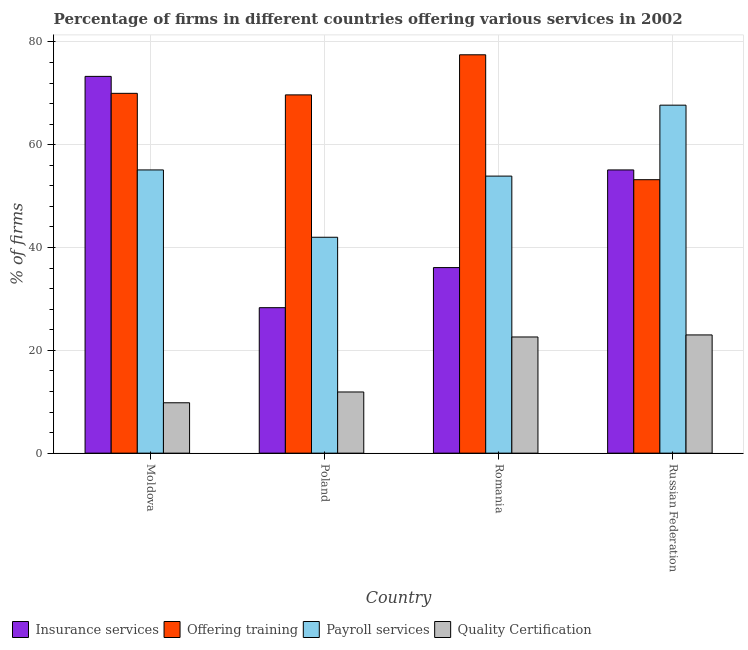Are the number of bars per tick equal to the number of legend labels?
Offer a very short reply. Yes. What is the label of the 1st group of bars from the left?
Your answer should be very brief. Moldova. In how many cases, is the number of bars for a given country not equal to the number of legend labels?
Give a very brief answer. 0. Across all countries, what is the maximum percentage of firms offering payroll services?
Ensure brevity in your answer.  67.7. Across all countries, what is the minimum percentage of firms offering payroll services?
Give a very brief answer. 42. In which country was the percentage of firms offering insurance services maximum?
Offer a terse response. Moldova. In which country was the percentage of firms offering insurance services minimum?
Offer a very short reply. Poland. What is the total percentage of firms offering training in the graph?
Keep it short and to the point. 270.4. What is the difference between the percentage of firms offering payroll services in Poland and that in Romania?
Make the answer very short. -11.9. What is the difference between the percentage of firms offering training in Romania and the percentage of firms offering insurance services in Russian Federation?
Ensure brevity in your answer.  22.4. What is the average percentage of firms offering quality certification per country?
Offer a terse response. 16.83. What is the difference between the percentage of firms offering training and percentage of firms offering insurance services in Poland?
Offer a very short reply. 41.4. What is the ratio of the percentage of firms offering training in Poland to that in Romania?
Your answer should be very brief. 0.9. Is the percentage of firms offering insurance services in Moldova less than that in Russian Federation?
Give a very brief answer. No. Is the difference between the percentage of firms offering insurance services in Romania and Russian Federation greater than the difference between the percentage of firms offering training in Romania and Russian Federation?
Your answer should be compact. No. What is the difference between the highest and the second highest percentage of firms offering training?
Your answer should be very brief. 7.5. In how many countries, is the percentage of firms offering training greater than the average percentage of firms offering training taken over all countries?
Ensure brevity in your answer.  3. Is it the case that in every country, the sum of the percentage of firms offering quality certification and percentage of firms offering payroll services is greater than the sum of percentage of firms offering training and percentage of firms offering insurance services?
Offer a terse response. No. What does the 2nd bar from the left in Romania represents?
Your answer should be compact. Offering training. What does the 4th bar from the right in Moldova represents?
Make the answer very short. Insurance services. Is it the case that in every country, the sum of the percentage of firms offering insurance services and percentage of firms offering training is greater than the percentage of firms offering payroll services?
Offer a very short reply. Yes. How many bars are there?
Ensure brevity in your answer.  16. Does the graph contain grids?
Offer a very short reply. Yes. Where does the legend appear in the graph?
Make the answer very short. Bottom left. How are the legend labels stacked?
Keep it short and to the point. Horizontal. What is the title of the graph?
Your answer should be very brief. Percentage of firms in different countries offering various services in 2002. Does "Environmental sustainability" appear as one of the legend labels in the graph?
Offer a very short reply. No. What is the label or title of the X-axis?
Your response must be concise. Country. What is the label or title of the Y-axis?
Your answer should be very brief. % of firms. What is the % of firms of Insurance services in Moldova?
Make the answer very short. 73.3. What is the % of firms in Payroll services in Moldova?
Make the answer very short. 55.1. What is the % of firms in Insurance services in Poland?
Give a very brief answer. 28.3. What is the % of firms in Offering training in Poland?
Offer a very short reply. 69.7. What is the % of firms of Insurance services in Romania?
Your response must be concise. 36.1. What is the % of firms in Offering training in Romania?
Provide a short and direct response. 77.5. What is the % of firms of Payroll services in Romania?
Your answer should be compact. 53.9. What is the % of firms of Quality Certification in Romania?
Offer a very short reply. 22.6. What is the % of firms of Insurance services in Russian Federation?
Offer a terse response. 55.1. What is the % of firms of Offering training in Russian Federation?
Offer a terse response. 53.2. What is the % of firms in Payroll services in Russian Federation?
Offer a terse response. 67.7. What is the % of firms in Quality Certification in Russian Federation?
Your response must be concise. 23. Across all countries, what is the maximum % of firms in Insurance services?
Provide a succinct answer. 73.3. Across all countries, what is the maximum % of firms of Offering training?
Make the answer very short. 77.5. Across all countries, what is the maximum % of firms in Payroll services?
Ensure brevity in your answer.  67.7. Across all countries, what is the minimum % of firms of Insurance services?
Keep it short and to the point. 28.3. Across all countries, what is the minimum % of firms in Offering training?
Provide a succinct answer. 53.2. Across all countries, what is the minimum % of firms of Payroll services?
Provide a short and direct response. 42. Across all countries, what is the minimum % of firms of Quality Certification?
Keep it short and to the point. 9.8. What is the total % of firms of Insurance services in the graph?
Make the answer very short. 192.8. What is the total % of firms in Offering training in the graph?
Give a very brief answer. 270.4. What is the total % of firms in Payroll services in the graph?
Provide a succinct answer. 218.7. What is the total % of firms of Quality Certification in the graph?
Your response must be concise. 67.3. What is the difference between the % of firms in Payroll services in Moldova and that in Poland?
Your response must be concise. 13.1. What is the difference between the % of firms of Quality Certification in Moldova and that in Poland?
Ensure brevity in your answer.  -2.1. What is the difference between the % of firms in Insurance services in Moldova and that in Romania?
Your answer should be compact. 37.2. What is the difference between the % of firms in Offering training in Moldova and that in Romania?
Offer a very short reply. -7.5. What is the difference between the % of firms of Quality Certification in Moldova and that in Romania?
Offer a terse response. -12.8. What is the difference between the % of firms of Insurance services in Moldova and that in Russian Federation?
Your answer should be compact. 18.2. What is the difference between the % of firms of Offering training in Moldova and that in Russian Federation?
Your response must be concise. 16.8. What is the difference between the % of firms of Quality Certification in Poland and that in Romania?
Give a very brief answer. -10.7. What is the difference between the % of firms of Insurance services in Poland and that in Russian Federation?
Offer a terse response. -26.8. What is the difference between the % of firms of Offering training in Poland and that in Russian Federation?
Your answer should be very brief. 16.5. What is the difference between the % of firms of Payroll services in Poland and that in Russian Federation?
Keep it short and to the point. -25.7. What is the difference between the % of firms in Insurance services in Romania and that in Russian Federation?
Offer a very short reply. -19. What is the difference between the % of firms of Offering training in Romania and that in Russian Federation?
Offer a very short reply. 24.3. What is the difference between the % of firms in Payroll services in Romania and that in Russian Federation?
Offer a terse response. -13.8. What is the difference between the % of firms of Insurance services in Moldova and the % of firms of Offering training in Poland?
Your answer should be compact. 3.6. What is the difference between the % of firms in Insurance services in Moldova and the % of firms in Payroll services in Poland?
Your response must be concise. 31.3. What is the difference between the % of firms of Insurance services in Moldova and the % of firms of Quality Certification in Poland?
Ensure brevity in your answer.  61.4. What is the difference between the % of firms in Offering training in Moldova and the % of firms in Quality Certification in Poland?
Make the answer very short. 58.1. What is the difference between the % of firms in Payroll services in Moldova and the % of firms in Quality Certification in Poland?
Your answer should be compact. 43.2. What is the difference between the % of firms of Insurance services in Moldova and the % of firms of Offering training in Romania?
Make the answer very short. -4.2. What is the difference between the % of firms in Insurance services in Moldova and the % of firms in Payroll services in Romania?
Keep it short and to the point. 19.4. What is the difference between the % of firms of Insurance services in Moldova and the % of firms of Quality Certification in Romania?
Offer a terse response. 50.7. What is the difference between the % of firms of Offering training in Moldova and the % of firms of Quality Certification in Romania?
Your response must be concise. 47.4. What is the difference between the % of firms of Payroll services in Moldova and the % of firms of Quality Certification in Romania?
Make the answer very short. 32.5. What is the difference between the % of firms in Insurance services in Moldova and the % of firms in Offering training in Russian Federation?
Your answer should be compact. 20.1. What is the difference between the % of firms of Insurance services in Moldova and the % of firms of Quality Certification in Russian Federation?
Give a very brief answer. 50.3. What is the difference between the % of firms in Offering training in Moldova and the % of firms in Payroll services in Russian Federation?
Make the answer very short. 2.3. What is the difference between the % of firms of Payroll services in Moldova and the % of firms of Quality Certification in Russian Federation?
Offer a very short reply. 32.1. What is the difference between the % of firms of Insurance services in Poland and the % of firms of Offering training in Romania?
Keep it short and to the point. -49.2. What is the difference between the % of firms in Insurance services in Poland and the % of firms in Payroll services in Romania?
Keep it short and to the point. -25.6. What is the difference between the % of firms of Offering training in Poland and the % of firms of Payroll services in Romania?
Ensure brevity in your answer.  15.8. What is the difference between the % of firms of Offering training in Poland and the % of firms of Quality Certification in Romania?
Give a very brief answer. 47.1. What is the difference between the % of firms of Insurance services in Poland and the % of firms of Offering training in Russian Federation?
Ensure brevity in your answer.  -24.9. What is the difference between the % of firms of Insurance services in Poland and the % of firms of Payroll services in Russian Federation?
Keep it short and to the point. -39.4. What is the difference between the % of firms in Offering training in Poland and the % of firms in Quality Certification in Russian Federation?
Your response must be concise. 46.7. What is the difference between the % of firms in Payroll services in Poland and the % of firms in Quality Certification in Russian Federation?
Offer a very short reply. 19. What is the difference between the % of firms of Insurance services in Romania and the % of firms of Offering training in Russian Federation?
Offer a terse response. -17.1. What is the difference between the % of firms in Insurance services in Romania and the % of firms in Payroll services in Russian Federation?
Give a very brief answer. -31.6. What is the difference between the % of firms in Offering training in Romania and the % of firms in Quality Certification in Russian Federation?
Offer a very short reply. 54.5. What is the difference between the % of firms in Payroll services in Romania and the % of firms in Quality Certification in Russian Federation?
Provide a short and direct response. 30.9. What is the average % of firms of Insurance services per country?
Your answer should be very brief. 48.2. What is the average % of firms in Offering training per country?
Give a very brief answer. 67.6. What is the average % of firms in Payroll services per country?
Make the answer very short. 54.67. What is the average % of firms in Quality Certification per country?
Your answer should be very brief. 16.82. What is the difference between the % of firms in Insurance services and % of firms in Offering training in Moldova?
Provide a short and direct response. 3.3. What is the difference between the % of firms of Insurance services and % of firms of Quality Certification in Moldova?
Give a very brief answer. 63.5. What is the difference between the % of firms of Offering training and % of firms of Quality Certification in Moldova?
Make the answer very short. 60.2. What is the difference between the % of firms in Payroll services and % of firms in Quality Certification in Moldova?
Give a very brief answer. 45.3. What is the difference between the % of firms of Insurance services and % of firms of Offering training in Poland?
Give a very brief answer. -41.4. What is the difference between the % of firms of Insurance services and % of firms of Payroll services in Poland?
Your answer should be compact. -13.7. What is the difference between the % of firms of Insurance services and % of firms of Quality Certification in Poland?
Your response must be concise. 16.4. What is the difference between the % of firms in Offering training and % of firms in Payroll services in Poland?
Keep it short and to the point. 27.7. What is the difference between the % of firms of Offering training and % of firms of Quality Certification in Poland?
Your response must be concise. 57.8. What is the difference between the % of firms in Payroll services and % of firms in Quality Certification in Poland?
Keep it short and to the point. 30.1. What is the difference between the % of firms of Insurance services and % of firms of Offering training in Romania?
Give a very brief answer. -41.4. What is the difference between the % of firms in Insurance services and % of firms in Payroll services in Romania?
Offer a very short reply. -17.8. What is the difference between the % of firms in Offering training and % of firms in Payroll services in Romania?
Make the answer very short. 23.6. What is the difference between the % of firms in Offering training and % of firms in Quality Certification in Romania?
Offer a very short reply. 54.9. What is the difference between the % of firms of Payroll services and % of firms of Quality Certification in Romania?
Provide a succinct answer. 31.3. What is the difference between the % of firms of Insurance services and % of firms of Payroll services in Russian Federation?
Provide a short and direct response. -12.6. What is the difference between the % of firms in Insurance services and % of firms in Quality Certification in Russian Federation?
Your response must be concise. 32.1. What is the difference between the % of firms of Offering training and % of firms of Quality Certification in Russian Federation?
Provide a short and direct response. 30.2. What is the difference between the % of firms of Payroll services and % of firms of Quality Certification in Russian Federation?
Ensure brevity in your answer.  44.7. What is the ratio of the % of firms in Insurance services in Moldova to that in Poland?
Your answer should be compact. 2.59. What is the ratio of the % of firms in Payroll services in Moldova to that in Poland?
Give a very brief answer. 1.31. What is the ratio of the % of firms in Quality Certification in Moldova to that in Poland?
Keep it short and to the point. 0.82. What is the ratio of the % of firms of Insurance services in Moldova to that in Romania?
Make the answer very short. 2.03. What is the ratio of the % of firms of Offering training in Moldova to that in Romania?
Offer a very short reply. 0.9. What is the ratio of the % of firms in Payroll services in Moldova to that in Romania?
Provide a short and direct response. 1.02. What is the ratio of the % of firms of Quality Certification in Moldova to that in Romania?
Your answer should be compact. 0.43. What is the ratio of the % of firms of Insurance services in Moldova to that in Russian Federation?
Your response must be concise. 1.33. What is the ratio of the % of firms of Offering training in Moldova to that in Russian Federation?
Provide a short and direct response. 1.32. What is the ratio of the % of firms of Payroll services in Moldova to that in Russian Federation?
Provide a short and direct response. 0.81. What is the ratio of the % of firms in Quality Certification in Moldova to that in Russian Federation?
Provide a succinct answer. 0.43. What is the ratio of the % of firms in Insurance services in Poland to that in Romania?
Make the answer very short. 0.78. What is the ratio of the % of firms in Offering training in Poland to that in Romania?
Offer a terse response. 0.9. What is the ratio of the % of firms in Payroll services in Poland to that in Romania?
Keep it short and to the point. 0.78. What is the ratio of the % of firms of Quality Certification in Poland to that in Romania?
Your response must be concise. 0.53. What is the ratio of the % of firms in Insurance services in Poland to that in Russian Federation?
Offer a very short reply. 0.51. What is the ratio of the % of firms in Offering training in Poland to that in Russian Federation?
Provide a succinct answer. 1.31. What is the ratio of the % of firms in Payroll services in Poland to that in Russian Federation?
Offer a terse response. 0.62. What is the ratio of the % of firms of Quality Certification in Poland to that in Russian Federation?
Provide a short and direct response. 0.52. What is the ratio of the % of firms of Insurance services in Romania to that in Russian Federation?
Your answer should be compact. 0.66. What is the ratio of the % of firms in Offering training in Romania to that in Russian Federation?
Your answer should be very brief. 1.46. What is the ratio of the % of firms in Payroll services in Romania to that in Russian Federation?
Offer a terse response. 0.8. What is the ratio of the % of firms of Quality Certification in Romania to that in Russian Federation?
Your answer should be very brief. 0.98. What is the difference between the highest and the second highest % of firms in Insurance services?
Give a very brief answer. 18.2. What is the difference between the highest and the lowest % of firms of Offering training?
Ensure brevity in your answer.  24.3. What is the difference between the highest and the lowest % of firms in Payroll services?
Provide a succinct answer. 25.7. What is the difference between the highest and the lowest % of firms in Quality Certification?
Make the answer very short. 13.2. 